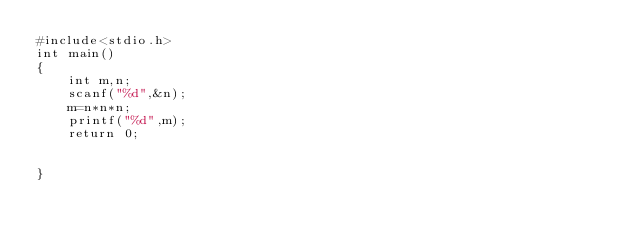Convert code to text. <code><loc_0><loc_0><loc_500><loc_500><_C_>#include<stdio.h>
int main()
{
    int m,n;
    scanf("%d",&n);
    m=n*n*n;
    printf("%d",m);
    return 0;


}
</code> 